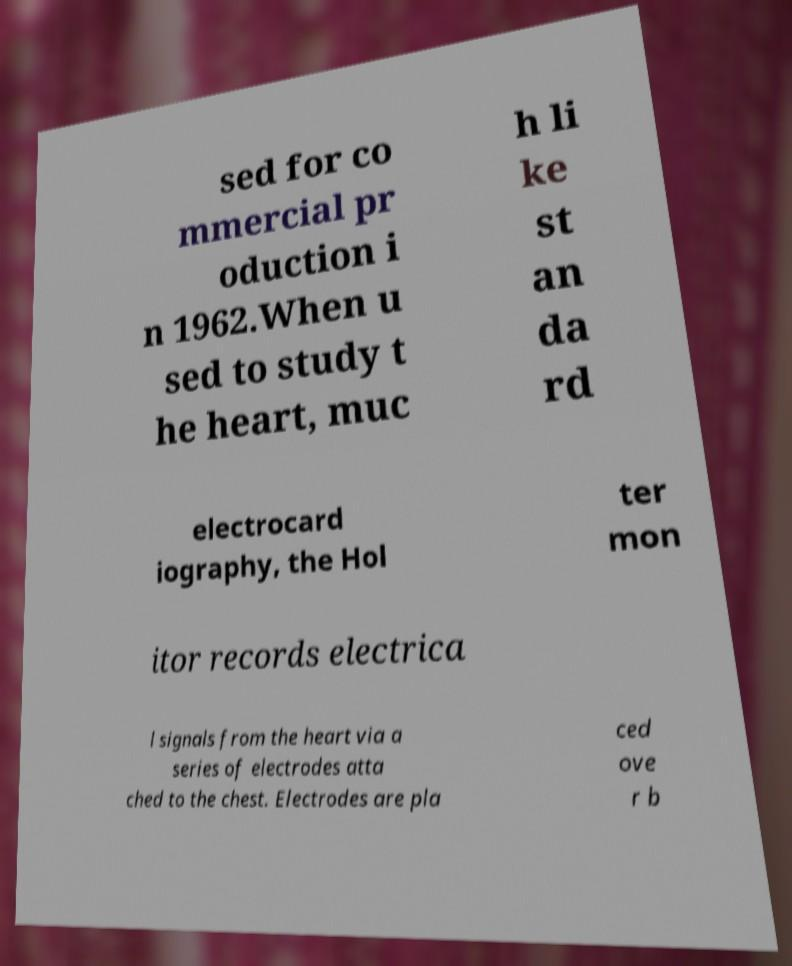Please identify and transcribe the text found in this image. sed for co mmercial pr oduction i n 1962.When u sed to study t he heart, muc h li ke st an da rd electrocard iography, the Hol ter mon itor records electrica l signals from the heart via a series of electrodes atta ched to the chest. Electrodes are pla ced ove r b 